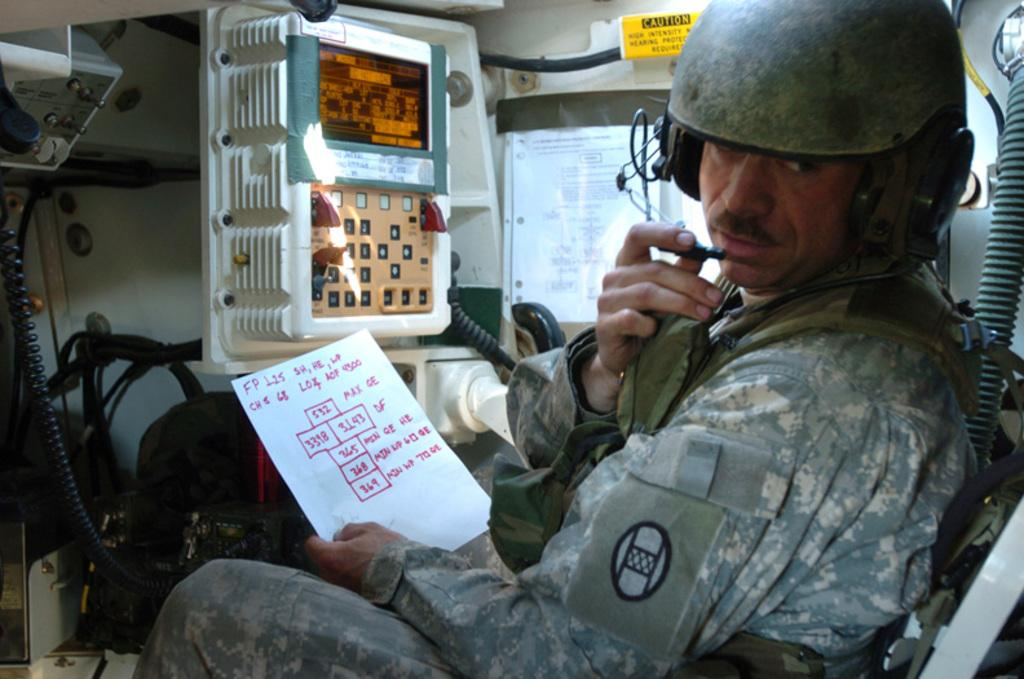What is the person in the image doing? The person is sitting in the image. What is the person holding? The person is holding papers. What can be seen in the background of the image? There is electrical equipment in the background of the image. What type of brush does the person's daughter use in the image? There is no daughter present in the image, and therefore no brush can be observed. 